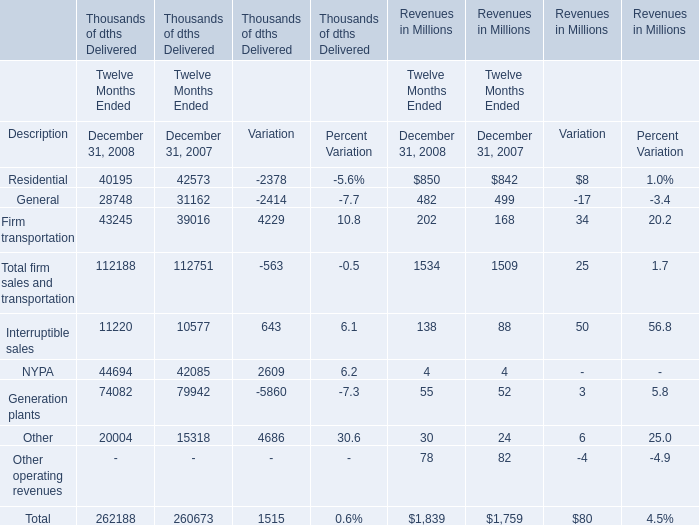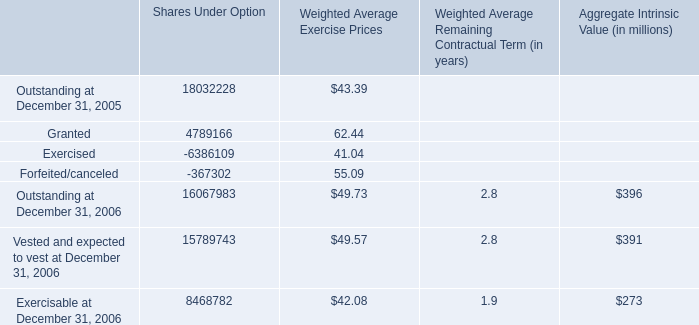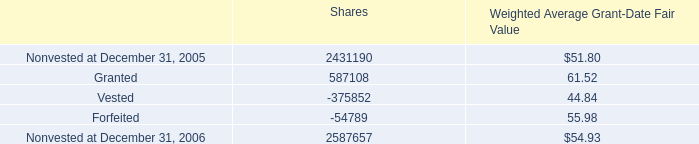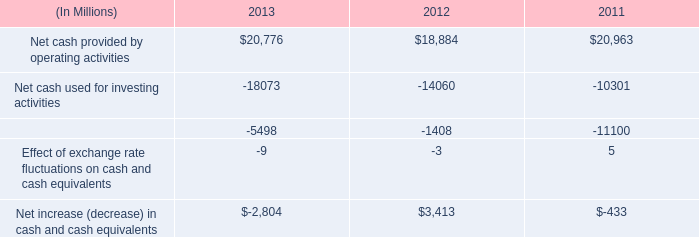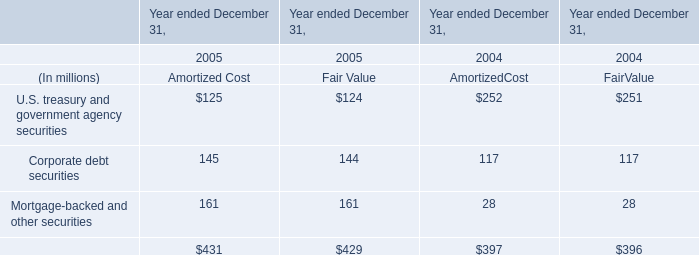In which years the Residential of Delivered is greater than Firm transportation of Delivered? 
Answer: 2007. 